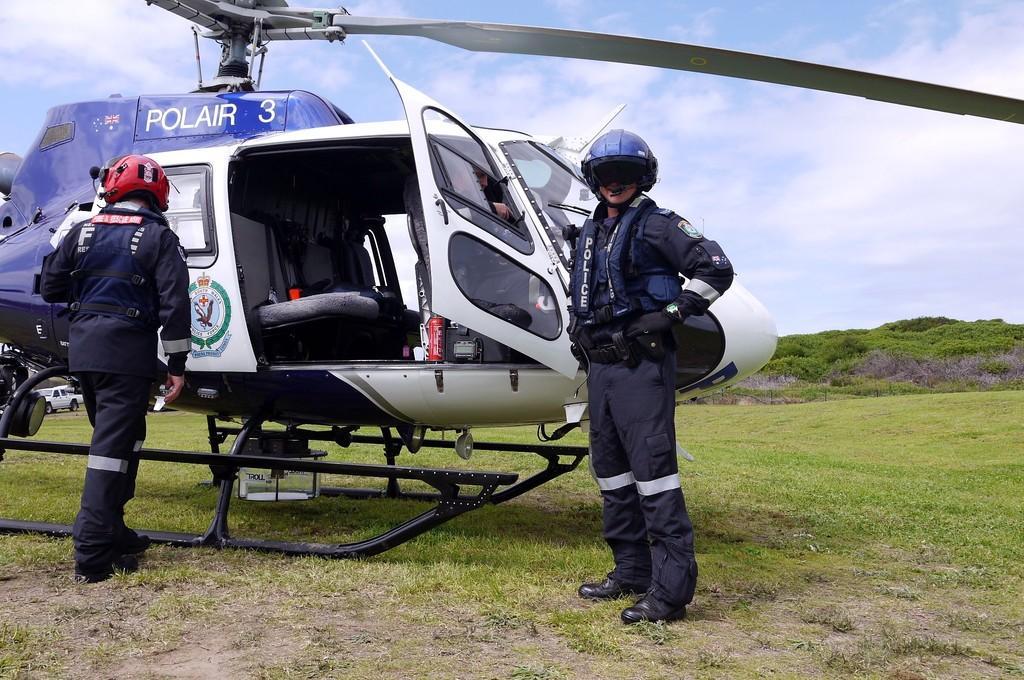How would you summarize this image in a sentence or two? In this image I can see an aircraft. I can see two people are standing and wearing helmets. I can see few trees, green grass and the sky is in blue and white color. 